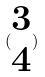Convert formula to latex. <formula><loc_0><loc_0><loc_500><loc_500>( \begin{matrix} 3 \\ 4 \end{matrix} )</formula> 